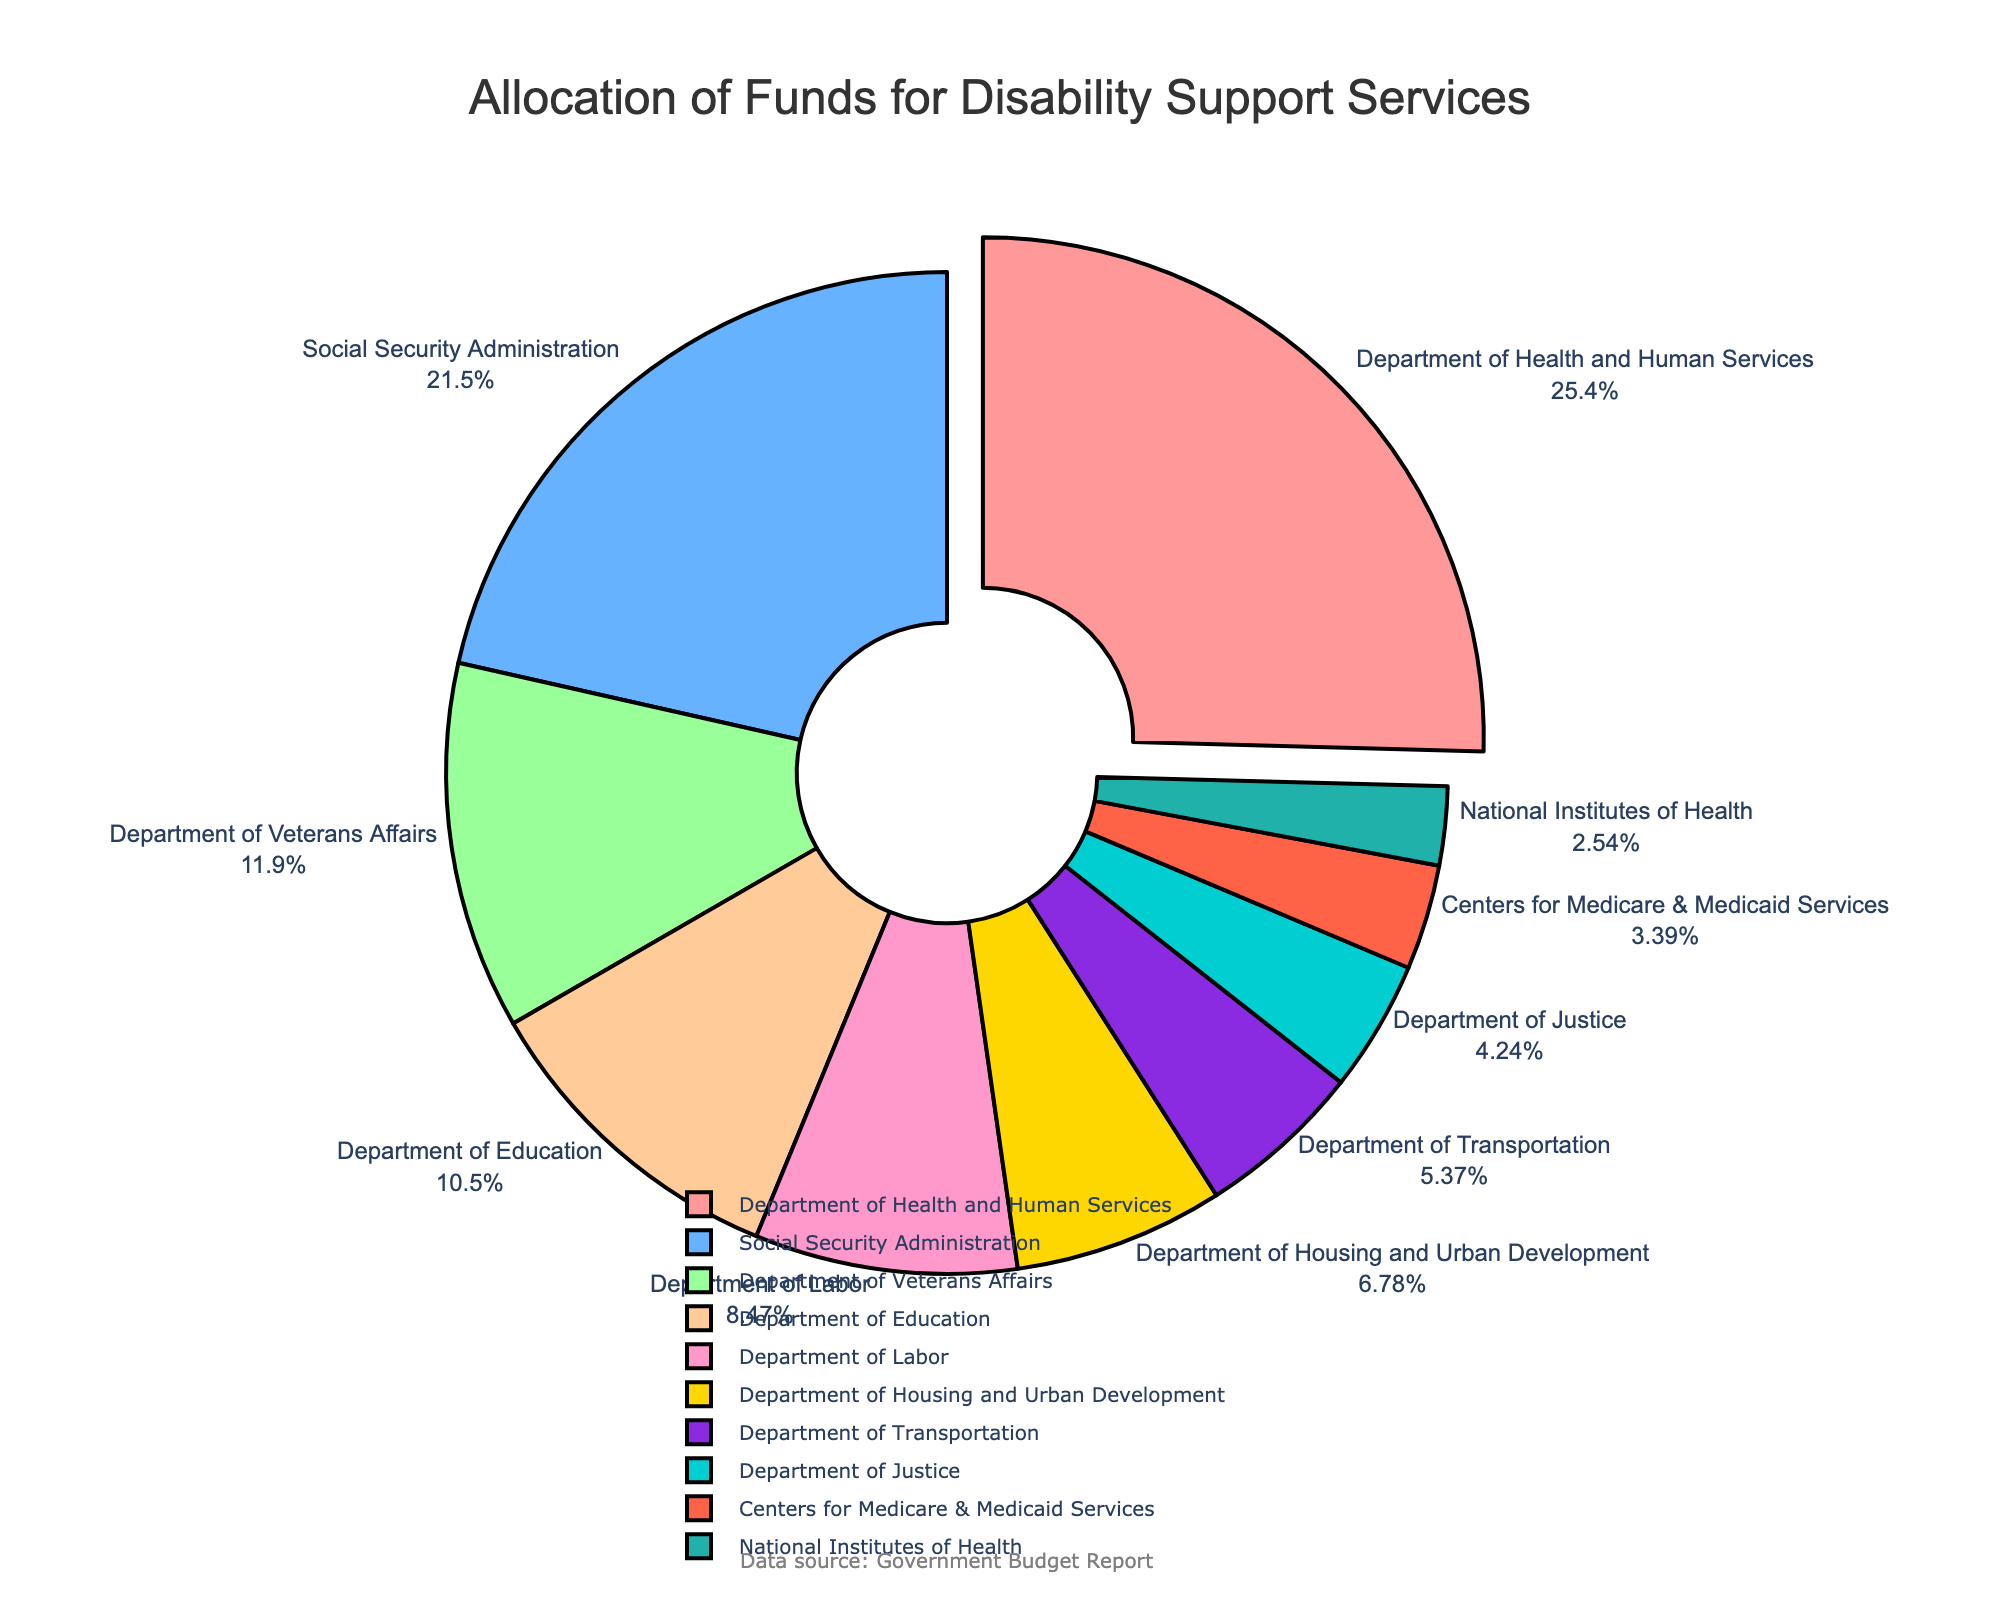What percentage of the total funds is allocated to the Department of Health and Human Services? The pie chart shows that the Department of Health and Human Services is represented by the largest segment, and it indicates that this department receives the highest allocation. The exact percentage is marked on the chart next to the department’s label.
Answer: 26.3% Which department receives the smallest allocation of funds? By visually inspecting the pie chart, the smallest segment corresponds to the National Institutes of Health, based on its size compared to the other segments.
Answer: National Institutes of Health How does the allocation for the Department of Veterans Affairs compare to the allocation for the Department of Education? First, locate the segments for the Department of Veterans Affairs and the Department of Education on the pie chart. The size of the segment for the Department of Veterans Affairs is larger than that of the Department of Education, indicating it receives more funds.
Answer: The Department of Veterans Affairs receives more funds than the Department of Education What is the sum of the allocations for the Department of Labor and the Department of Housing and Urban Development? According to the pie chart, the Department of Labor receives 150 million, and the Department of Housing and Urban Development receives 120 million. Adding these amounts gives 150 + 120 = 270 million.
Answer: 270 million Which department’s allocation is represented by the color blue? The chart uses distinct colors for each segment. The segment that uses the color blue corresponds to the Social Security Administration.
Answer: Social Security Administration What is the allocation difference between the Social Security Administration and Centers for Medicare & Medicaid Services? Locate both segments on the pie chart; the Social Security Administration has an allocation of 380 million, and the Centers for Medicare & Medicaid Services have 60 million. Subtracting the smaller allocation from the larger gives 380 - 60 = 320 million.
Answer: 320 million What is the median allocation of the listed departments? To find the median, list the allocations in ascending order: 45, 60, 75, 95, 120, 150, 185, 210, 380, 450. The median is the middle value of this ordered list, which in an even-numbered list is the average of the 5th and 6th values. Thus, the median is (120 + 150) / 2 = 135 million.
Answer: 135 million Which department has been allocated funds higher than the Department of Labor but lower than the Department of Veterans Affairs? From the pie chart, the Department of Labor has 150 million, and the Department of Veterans Affairs has 210 million. The Department of Education, with an allocation of 185 million, fits this criterion.
Answer: Department of Education How does the allocation for the Department of Justice compare to the allocation for the Department of Transportation? The pie chart shows that the Department of Justice receives 75 million, while the Department of Transportation receives 95 million. The Department of Transportation receives more funds than the Department of Justice.
Answer: The Department of Transportation receives more funds than the Department of Justice 